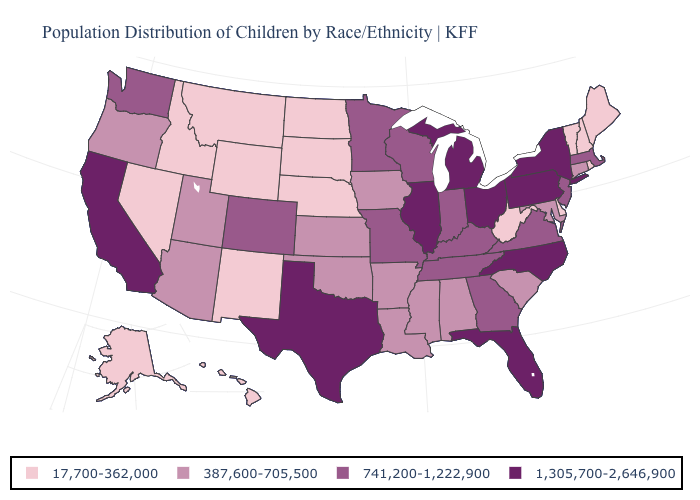Which states have the lowest value in the West?
Concise answer only. Alaska, Hawaii, Idaho, Montana, Nevada, New Mexico, Wyoming. What is the value of Michigan?
Be succinct. 1,305,700-2,646,900. Which states have the lowest value in the MidWest?
Give a very brief answer. Nebraska, North Dakota, South Dakota. Name the states that have a value in the range 387,600-705,500?
Answer briefly. Alabama, Arizona, Arkansas, Connecticut, Iowa, Kansas, Louisiana, Maryland, Mississippi, Oklahoma, Oregon, South Carolina, Utah. Name the states that have a value in the range 1,305,700-2,646,900?
Keep it brief. California, Florida, Illinois, Michigan, New York, North Carolina, Ohio, Pennsylvania, Texas. Among the states that border Alabama , which have the lowest value?
Write a very short answer. Mississippi. Name the states that have a value in the range 1,305,700-2,646,900?
Write a very short answer. California, Florida, Illinois, Michigan, New York, North Carolina, Ohio, Pennsylvania, Texas. Among the states that border Wisconsin , which have the lowest value?
Short answer required. Iowa. What is the value of Oregon?
Answer briefly. 387,600-705,500. Name the states that have a value in the range 1,305,700-2,646,900?
Short answer required. California, Florida, Illinois, Michigan, New York, North Carolina, Ohio, Pennsylvania, Texas. What is the value of Indiana?
Concise answer only. 741,200-1,222,900. Name the states that have a value in the range 17,700-362,000?
Concise answer only. Alaska, Delaware, Hawaii, Idaho, Maine, Montana, Nebraska, Nevada, New Hampshire, New Mexico, North Dakota, Rhode Island, South Dakota, Vermont, West Virginia, Wyoming. Name the states that have a value in the range 387,600-705,500?
Short answer required. Alabama, Arizona, Arkansas, Connecticut, Iowa, Kansas, Louisiana, Maryland, Mississippi, Oklahoma, Oregon, South Carolina, Utah. Does the first symbol in the legend represent the smallest category?
Write a very short answer. Yes. 